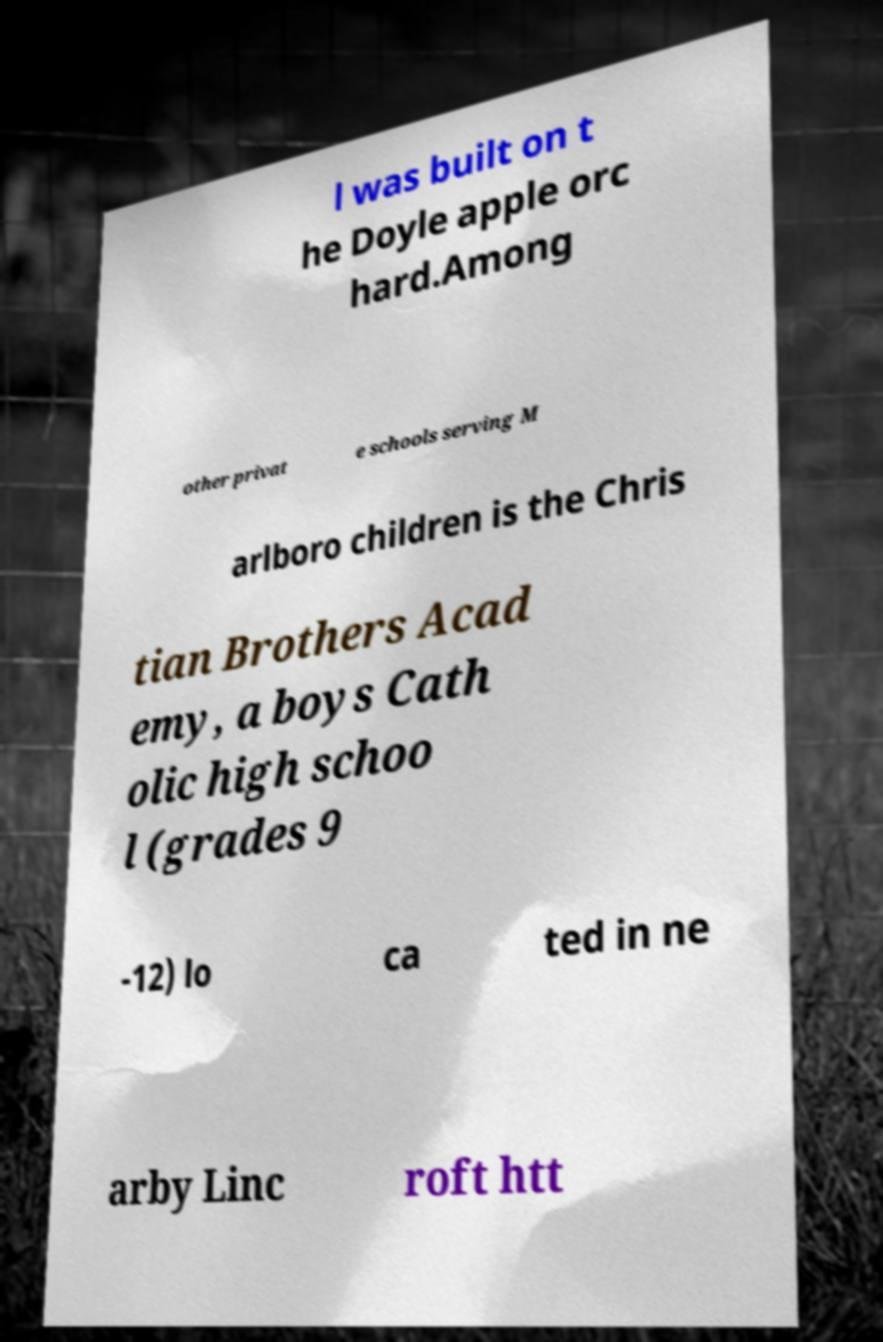Could you assist in decoding the text presented in this image and type it out clearly? l was built on t he Doyle apple orc hard.Among other privat e schools serving M arlboro children is the Chris tian Brothers Acad emy, a boys Cath olic high schoo l (grades 9 -12) lo ca ted in ne arby Linc roft htt 